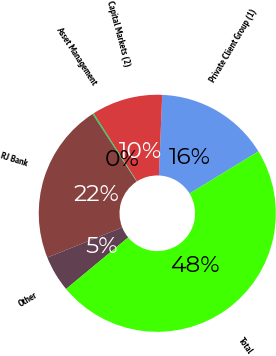Convert chart to OTSL. <chart><loc_0><loc_0><loc_500><loc_500><pie_chart><fcel>Private Client Group (1)<fcel>Capital Markets (2)<fcel>Asset Management<fcel>RJ Bank<fcel>Other<fcel>Total<nl><fcel>15.6%<fcel>9.69%<fcel>0.18%<fcel>21.88%<fcel>4.94%<fcel>47.71%<nl></chart> 